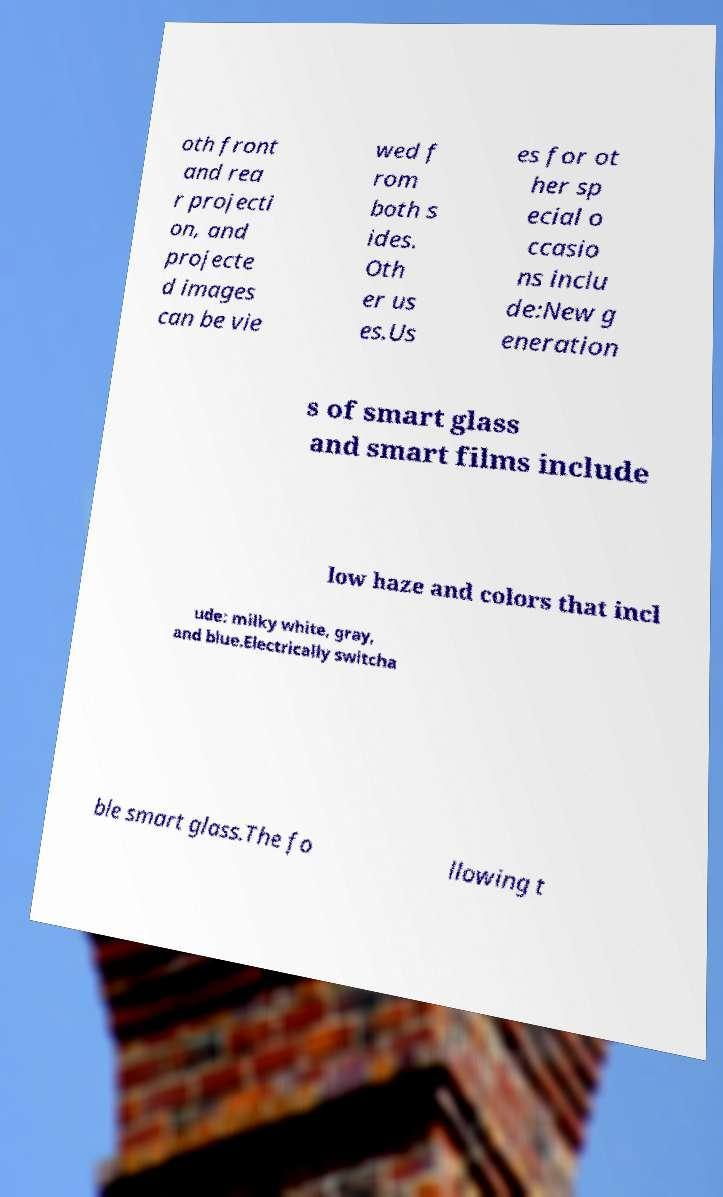Could you assist in decoding the text presented in this image and type it out clearly? oth front and rea r projecti on, and projecte d images can be vie wed f rom both s ides. Oth er us es.Us es for ot her sp ecial o ccasio ns inclu de:New g eneration s of smart glass and smart films include low haze and colors that incl ude: milky white, gray, and blue.Electrically switcha ble smart glass.The fo llowing t 